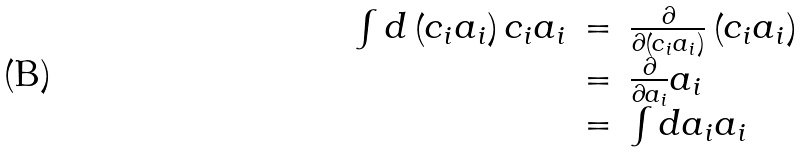<formula> <loc_0><loc_0><loc_500><loc_500>\begin{array} { r c l } \int d \left ( c _ { i } a _ { i } \right ) c _ { i } a _ { i } & = & \frac { \partial } { \partial \left ( c _ { i } a _ { i } \right ) } \left ( c _ { i } a _ { i } \right ) \\ & = & \frac { \partial } { \partial a _ { i } } a _ { i } \\ & = & \int d a _ { i } a _ { i } \end{array}</formula> 